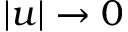<formula> <loc_0><loc_0><loc_500><loc_500>| u | \rightarrow 0</formula> 